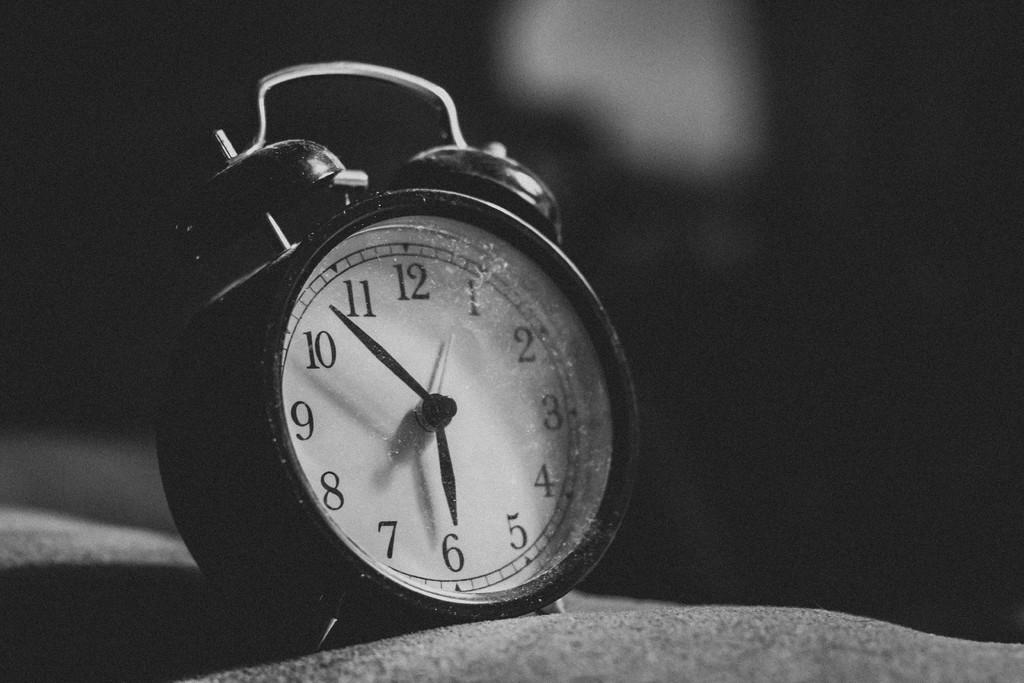What is the time?
Provide a short and direct response. 5:53. What number is the hour hand nearest to?
Keep it short and to the point. 6. 